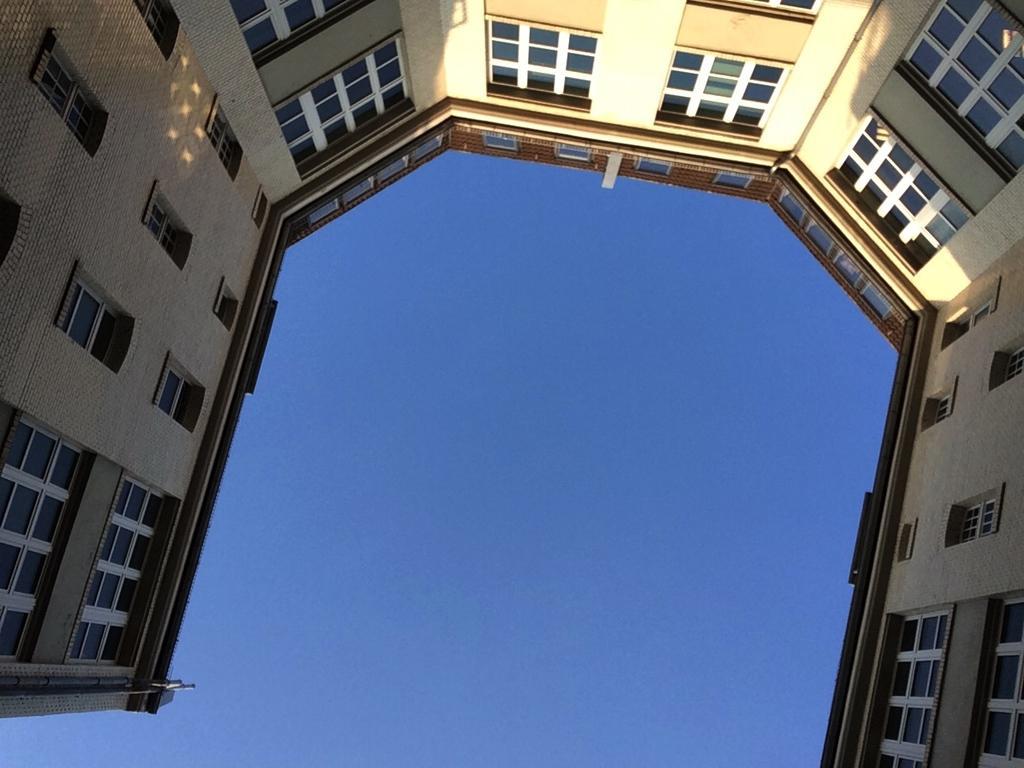Describe this image in one or two sentences. In this picture we can see building and windows. We can see sky in blue color. 